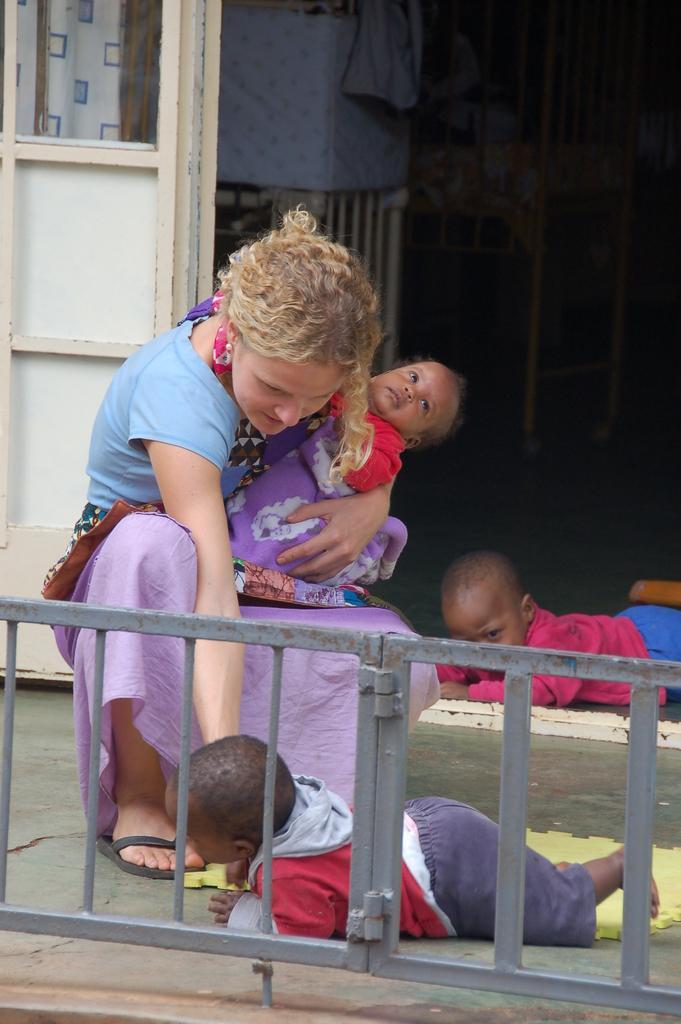Can you describe this image briefly? In this image I see a woman who is holding a baby and I see 2 children on the floor and I see the fencing over here. In the background I see the wooden thing over here. 